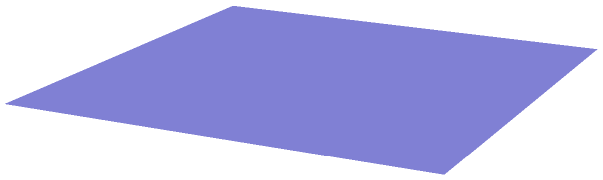Your grandparent has drawn a pyramid with a square base to help you understand volume calculations. The base of the pyramid is a square with side length 2 units, and the height of the pyramid is 3 units. Calculate the volume of this pyramid. Let's approach this step-by-step:

1) The formula for the volume of a pyramid is:

   $$V = \frac{1}{3} \times B \times h$$

   Where $V$ is the volume, $B$ is the area of the base, and $h$ is the height of the pyramid.

2) We need to find the area of the base (B):
   - The base is a square with side length 2 units
   - Area of a square = side length squared
   - $B = 2^2 = 4$ square units

3) We're given the height (h):
   - $h = 3$ units

4) Now, let's substitute these values into our formula:

   $$V = \frac{1}{3} \times 4 \times 3$$

5) Let's calculate:
   
   $$V = \frac{4 \times 3}{3} = 4$$ cubic units

Therefore, the volume of the pyramid is 4 cubic units.
Answer: 4 cubic units 